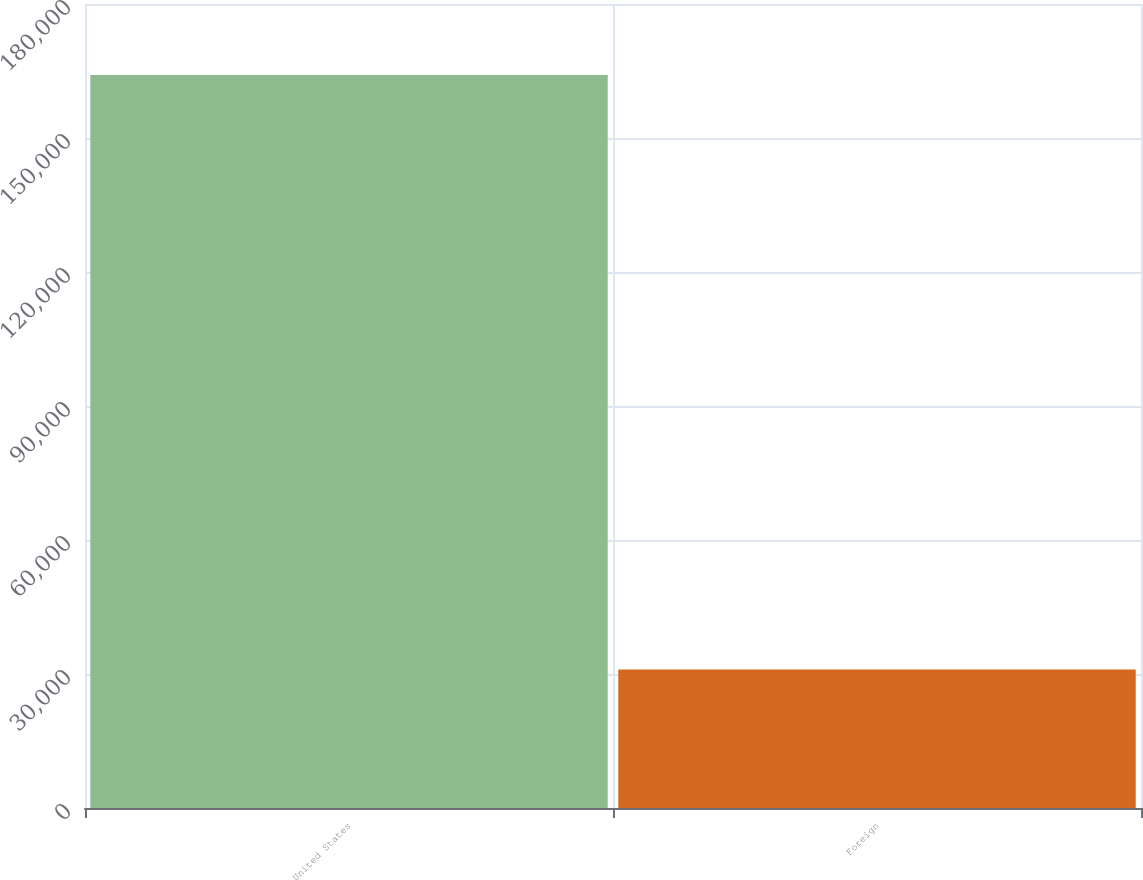Convert chart to OTSL. <chart><loc_0><loc_0><loc_500><loc_500><bar_chart><fcel>United States<fcel>Foreign<nl><fcel>164094<fcel>30980<nl></chart> 